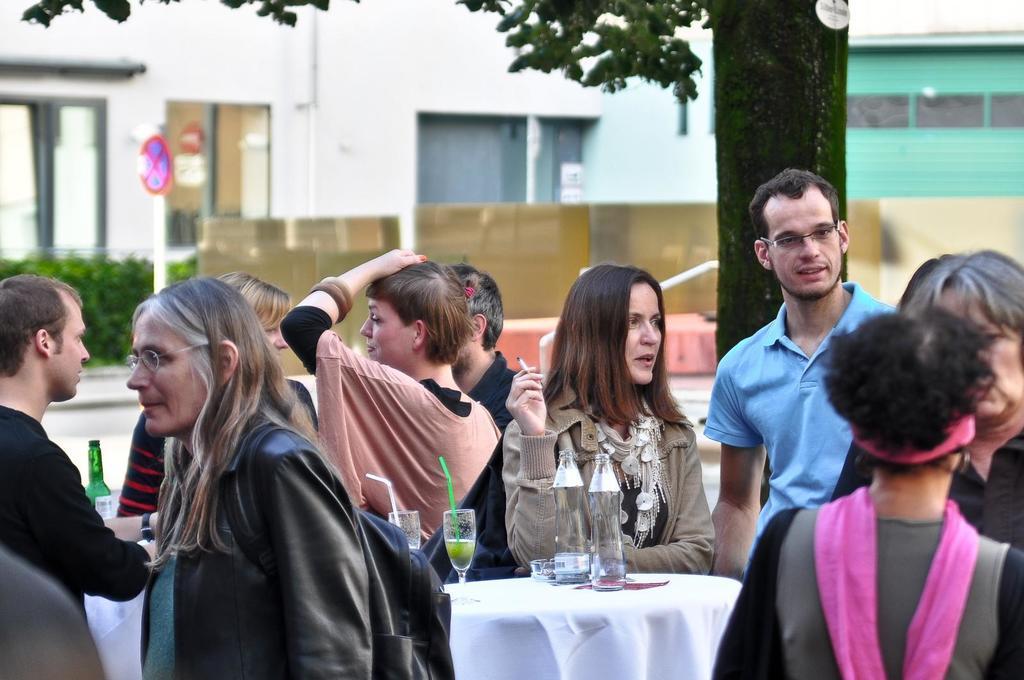Could you give a brief overview of what you see in this image? In the image there are few people standing. And there is a table with bottles and glass with liquid and straws in it. There is a lady holding a cigarette in her hand. Behind them there is a tree trunk and also there are leaves. And also there are buildings with glass windows and wall. And also there are bushes. There is a pole with sign board. 